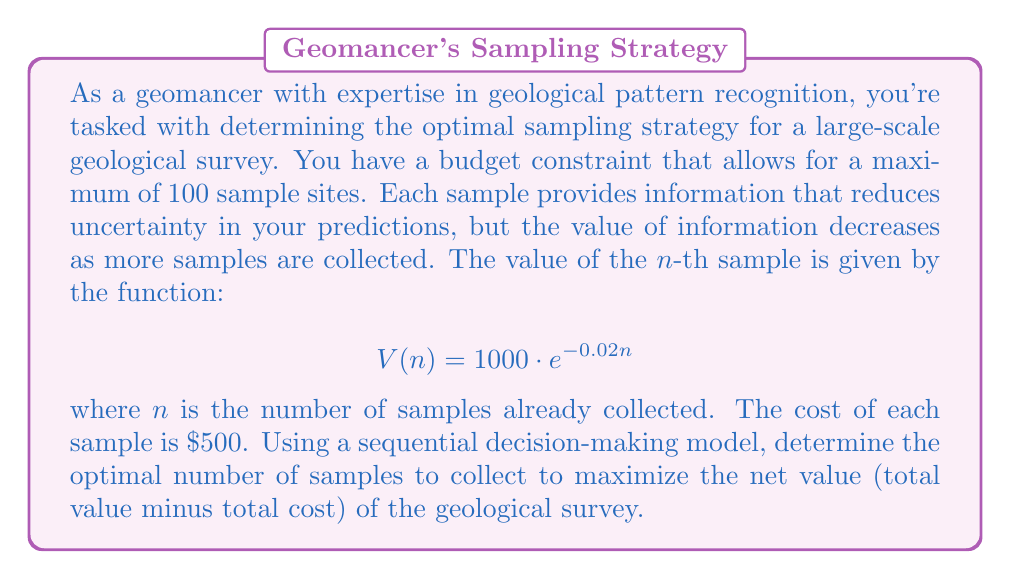Can you solve this math problem? To solve this problem, we need to use principles from sequential decision-making and optimization. Let's approach this step-by-step:

1) First, let's define our objective function. We want to maximize the net value, which is the total value minus the total cost:

   $$\text{Net Value} = \text{Total Value} - \text{Total Cost}$$

2) The total value is the sum of the values of each sample:

   $$\text{Total Value} = \sum_{i=1}^n V(i) = \sum_{i=1}^n 1000 \cdot e^{-0.02i}$$

3) The total cost is simply $500 times the number of samples:

   $$\text{Total Cost} = 500n$$

4) Therefore, our objective function is:

   $$\text{Net Value} = \sum_{i=1}^n 1000 \cdot e^{-0.02i} - 500n$$

5) To find the maximum, we need to find the point where the marginal benefit equals the marginal cost. In other words, we need to find $n$ where:

   $$V(n) = 500$$

6) Solving this equation:

   $$1000 \cdot e^{-0.02n} = 500$$
   $$e^{-0.02n} = 0.5$$
   $$-0.02n = \ln(0.5)$$
   $$n = -\frac{\ln(0.5)}{0.02} \approx 34.66$$

7) Since we can only take a whole number of samples, we need to check both $n = 34$ and $n = 35$ to see which gives a higher net value.

8) For $n = 34$:
   Net Value = $23,377.76 - 17,000 = 6,377.76$

   For $n = 35$:
   Net Value = $23,864.13 - 17,500 = 6,364.13$

9) Therefore, the optimal number of samples is 34.
Answer: The optimal number of samples to collect is 34, which maximizes the net value of the geological survey at $6,377.76. 